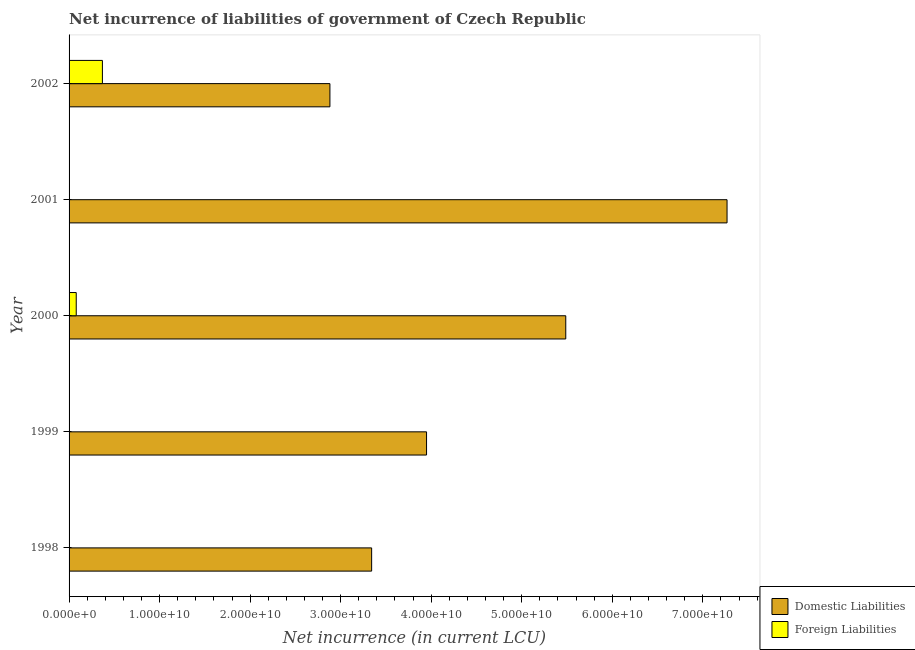How many different coloured bars are there?
Give a very brief answer. 2. Are the number of bars per tick equal to the number of legend labels?
Keep it short and to the point. No. Are the number of bars on each tick of the Y-axis equal?
Keep it short and to the point. No. How many bars are there on the 3rd tick from the bottom?
Your answer should be very brief. 2. In how many cases, is the number of bars for a given year not equal to the number of legend labels?
Offer a terse response. 3. What is the net incurrence of foreign liabilities in 2000?
Offer a very short reply. 7.92e+08. Across all years, what is the maximum net incurrence of domestic liabilities?
Offer a terse response. 7.27e+1. In which year was the net incurrence of domestic liabilities maximum?
Provide a succinct answer. 2001. What is the total net incurrence of foreign liabilities in the graph?
Provide a succinct answer. 4.47e+09. What is the difference between the net incurrence of foreign liabilities in 2000 and that in 2002?
Ensure brevity in your answer.  -2.89e+09. What is the difference between the net incurrence of domestic liabilities in 1998 and the net incurrence of foreign liabilities in 2002?
Provide a short and direct response. 2.97e+1. What is the average net incurrence of foreign liabilities per year?
Offer a terse response. 8.95e+08. In the year 2000, what is the difference between the net incurrence of foreign liabilities and net incurrence of domestic liabilities?
Your response must be concise. -5.41e+1. In how many years, is the net incurrence of domestic liabilities greater than 48000000000 LCU?
Offer a very short reply. 2. What is the ratio of the net incurrence of domestic liabilities in 1998 to that in 2002?
Your answer should be compact. 1.16. Is the net incurrence of foreign liabilities in 2000 less than that in 2002?
Offer a very short reply. Yes. What is the difference between the highest and the second highest net incurrence of domestic liabilities?
Offer a terse response. 1.78e+1. What is the difference between the highest and the lowest net incurrence of foreign liabilities?
Offer a terse response. 3.68e+09. Is the sum of the net incurrence of domestic liabilities in 2001 and 2002 greater than the maximum net incurrence of foreign liabilities across all years?
Provide a succinct answer. Yes. Are the values on the major ticks of X-axis written in scientific E-notation?
Your answer should be compact. Yes. Does the graph contain any zero values?
Give a very brief answer. Yes. Does the graph contain grids?
Give a very brief answer. No. What is the title of the graph?
Your answer should be very brief. Net incurrence of liabilities of government of Czech Republic. What is the label or title of the X-axis?
Ensure brevity in your answer.  Net incurrence (in current LCU). What is the label or title of the Y-axis?
Offer a very short reply. Year. What is the Net incurrence (in current LCU) of Domestic Liabilities in 1998?
Ensure brevity in your answer.  3.34e+1. What is the Net incurrence (in current LCU) in Domestic Liabilities in 1999?
Keep it short and to the point. 3.95e+1. What is the Net incurrence (in current LCU) in Domestic Liabilities in 2000?
Make the answer very short. 5.49e+1. What is the Net incurrence (in current LCU) of Foreign Liabilities in 2000?
Give a very brief answer. 7.92e+08. What is the Net incurrence (in current LCU) in Domestic Liabilities in 2001?
Offer a terse response. 7.27e+1. What is the Net incurrence (in current LCU) of Domestic Liabilities in 2002?
Offer a very short reply. 2.88e+1. What is the Net incurrence (in current LCU) of Foreign Liabilities in 2002?
Provide a short and direct response. 3.68e+09. Across all years, what is the maximum Net incurrence (in current LCU) in Domestic Liabilities?
Your answer should be compact. 7.27e+1. Across all years, what is the maximum Net incurrence (in current LCU) in Foreign Liabilities?
Offer a terse response. 3.68e+09. Across all years, what is the minimum Net incurrence (in current LCU) in Domestic Liabilities?
Provide a short and direct response. 2.88e+1. Across all years, what is the minimum Net incurrence (in current LCU) in Foreign Liabilities?
Ensure brevity in your answer.  0. What is the total Net incurrence (in current LCU) of Domestic Liabilities in the graph?
Provide a short and direct response. 2.29e+11. What is the total Net incurrence (in current LCU) in Foreign Liabilities in the graph?
Offer a very short reply. 4.47e+09. What is the difference between the Net incurrence (in current LCU) in Domestic Liabilities in 1998 and that in 1999?
Your answer should be compact. -6.06e+09. What is the difference between the Net incurrence (in current LCU) in Domestic Liabilities in 1998 and that in 2000?
Offer a very short reply. -2.14e+1. What is the difference between the Net incurrence (in current LCU) of Domestic Liabilities in 1998 and that in 2001?
Offer a terse response. -3.93e+1. What is the difference between the Net incurrence (in current LCU) in Domestic Liabilities in 1998 and that in 2002?
Keep it short and to the point. 4.61e+09. What is the difference between the Net incurrence (in current LCU) in Domestic Liabilities in 1999 and that in 2000?
Ensure brevity in your answer.  -1.54e+1. What is the difference between the Net incurrence (in current LCU) of Domestic Liabilities in 1999 and that in 2001?
Offer a very short reply. -3.32e+1. What is the difference between the Net incurrence (in current LCU) of Domestic Liabilities in 1999 and that in 2002?
Make the answer very short. 1.07e+1. What is the difference between the Net incurrence (in current LCU) in Domestic Liabilities in 2000 and that in 2001?
Provide a short and direct response. -1.78e+1. What is the difference between the Net incurrence (in current LCU) of Domestic Liabilities in 2000 and that in 2002?
Offer a very short reply. 2.61e+1. What is the difference between the Net incurrence (in current LCU) in Foreign Liabilities in 2000 and that in 2002?
Offer a very short reply. -2.89e+09. What is the difference between the Net incurrence (in current LCU) in Domestic Liabilities in 2001 and that in 2002?
Offer a very short reply. 4.39e+1. What is the difference between the Net incurrence (in current LCU) in Domestic Liabilities in 1998 and the Net incurrence (in current LCU) in Foreign Liabilities in 2000?
Provide a short and direct response. 3.26e+1. What is the difference between the Net incurrence (in current LCU) in Domestic Liabilities in 1998 and the Net incurrence (in current LCU) in Foreign Liabilities in 2002?
Your response must be concise. 2.97e+1. What is the difference between the Net incurrence (in current LCU) of Domestic Liabilities in 1999 and the Net incurrence (in current LCU) of Foreign Liabilities in 2000?
Make the answer very short. 3.87e+1. What is the difference between the Net incurrence (in current LCU) in Domestic Liabilities in 1999 and the Net incurrence (in current LCU) in Foreign Liabilities in 2002?
Your answer should be compact. 3.58e+1. What is the difference between the Net incurrence (in current LCU) of Domestic Liabilities in 2000 and the Net incurrence (in current LCU) of Foreign Liabilities in 2002?
Provide a succinct answer. 5.12e+1. What is the difference between the Net incurrence (in current LCU) in Domestic Liabilities in 2001 and the Net incurrence (in current LCU) in Foreign Liabilities in 2002?
Keep it short and to the point. 6.90e+1. What is the average Net incurrence (in current LCU) of Domestic Liabilities per year?
Provide a succinct answer. 4.59e+1. What is the average Net incurrence (in current LCU) in Foreign Liabilities per year?
Offer a terse response. 8.95e+08. In the year 2000, what is the difference between the Net incurrence (in current LCU) of Domestic Liabilities and Net incurrence (in current LCU) of Foreign Liabilities?
Keep it short and to the point. 5.41e+1. In the year 2002, what is the difference between the Net incurrence (in current LCU) of Domestic Liabilities and Net incurrence (in current LCU) of Foreign Liabilities?
Provide a short and direct response. 2.51e+1. What is the ratio of the Net incurrence (in current LCU) in Domestic Liabilities in 1998 to that in 1999?
Your answer should be compact. 0.85. What is the ratio of the Net incurrence (in current LCU) of Domestic Liabilities in 1998 to that in 2000?
Your response must be concise. 0.61. What is the ratio of the Net incurrence (in current LCU) in Domestic Liabilities in 1998 to that in 2001?
Offer a very short reply. 0.46. What is the ratio of the Net incurrence (in current LCU) of Domestic Liabilities in 1998 to that in 2002?
Ensure brevity in your answer.  1.16. What is the ratio of the Net incurrence (in current LCU) of Domestic Liabilities in 1999 to that in 2000?
Make the answer very short. 0.72. What is the ratio of the Net incurrence (in current LCU) in Domestic Liabilities in 1999 to that in 2001?
Give a very brief answer. 0.54. What is the ratio of the Net incurrence (in current LCU) in Domestic Liabilities in 1999 to that in 2002?
Provide a succinct answer. 1.37. What is the ratio of the Net incurrence (in current LCU) of Domestic Liabilities in 2000 to that in 2001?
Provide a succinct answer. 0.75. What is the ratio of the Net incurrence (in current LCU) of Domestic Liabilities in 2000 to that in 2002?
Ensure brevity in your answer.  1.9. What is the ratio of the Net incurrence (in current LCU) in Foreign Liabilities in 2000 to that in 2002?
Your answer should be compact. 0.22. What is the ratio of the Net incurrence (in current LCU) of Domestic Liabilities in 2001 to that in 2002?
Make the answer very short. 2.52. What is the difference between the highest and the second highest Net incurrence (in current LCU) in Domestic Liabilities?
Give a very brief answer. 1.78e+1. What is the difference between the highest and the lowest Net incurrence (in current LCU) of Domestic Liabilities?
Your response must be concise. 4.39e+1. What is the difference between the highest and the lowest Net incurrence (in current LCU) of Foreign Liabilities?
Provide a short and direct response. 3.68e+09. 